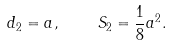Convert formula to latex. <formula><loc_0><loc_0><loc_500><loc_500>d _ { 2 } = a , \quad S _ { 2 } = \frac { 1 } { 8 } a ^ { 2 } .</formula> 